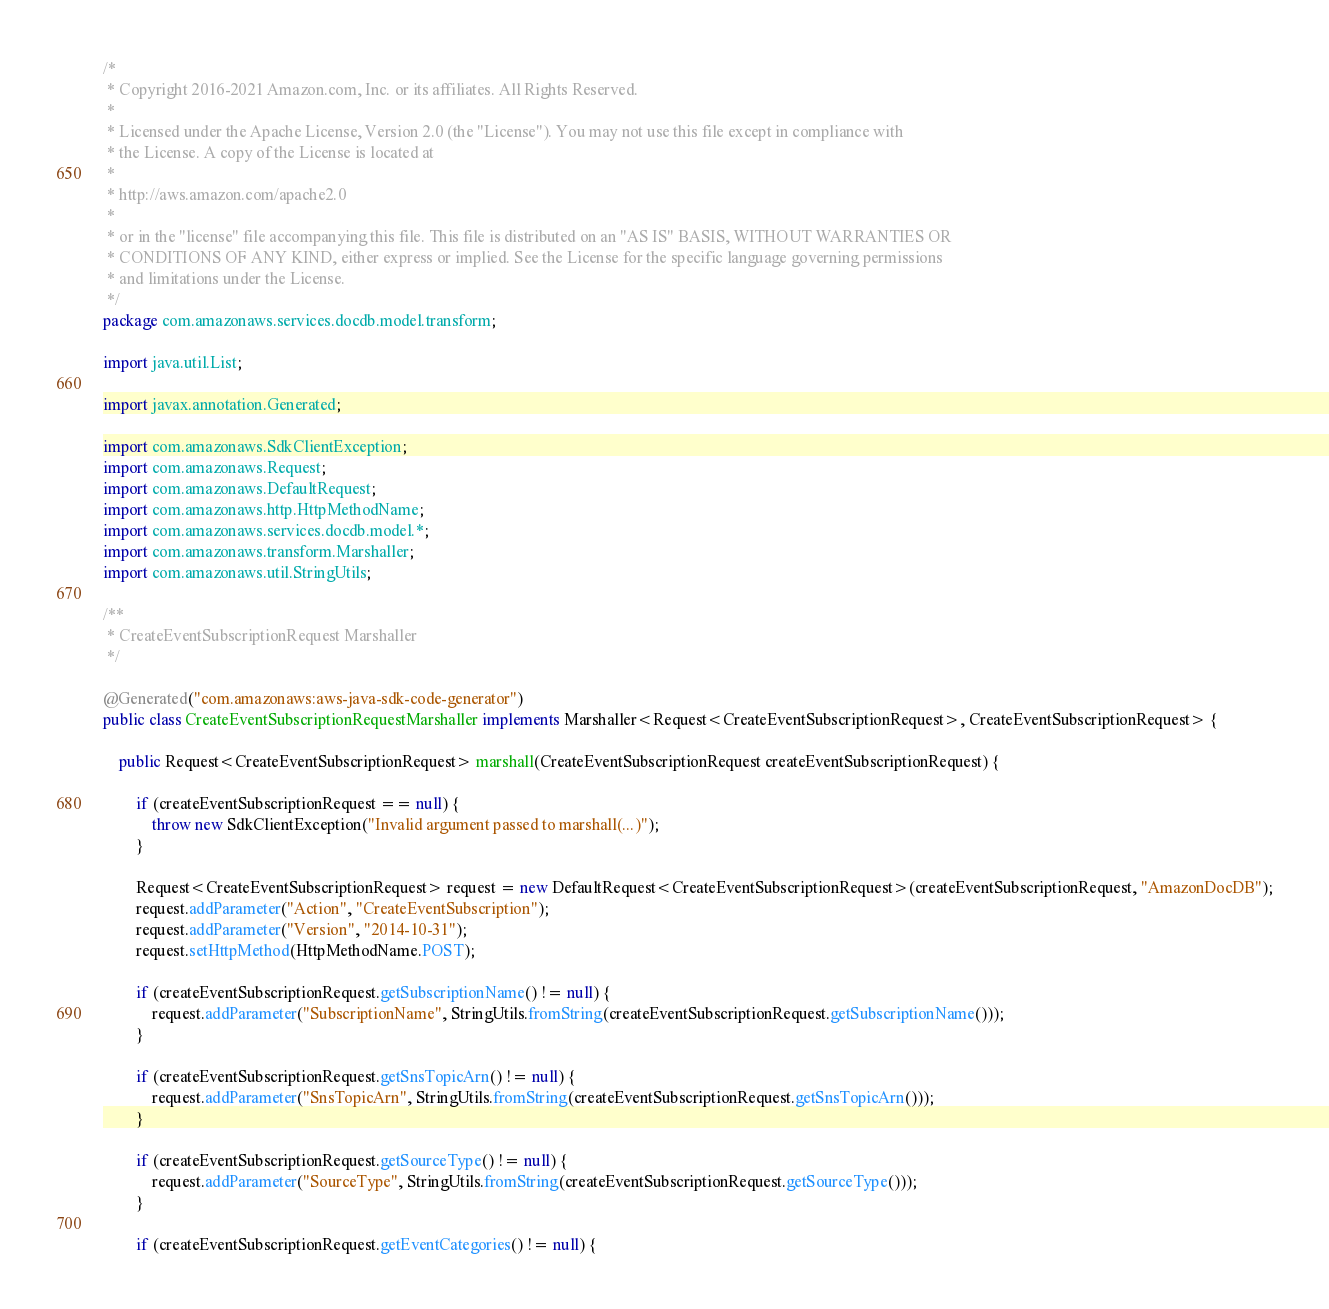<code> <loc_0><loc_0><loc_500><loc_500><_Java_>/*
 * Copyright 2016-2021 Amazon.com, Inc. or its affiliates. All Rights Reserved.
 * 
 * Licensed under the Apache License, Version 2.0 (the "License"). You may not use this file except in compliance with
 * the License. A copy of the License is located at
 * 
 * http://aws.amazon.com/apache2.0
 * 
 * or in the "license" file accompanying this file. This file is distributed on an "AS IS" BASIS, WITHOUT WARRANTIES OR
 * CONDITIONS OF ANY KIND, either express or implied. See the License for the specific language governing permissions
 * and limitations under the License.
 */
package com.amazonaws.services.docdb.model.transform;

import java.util.List;

import javax.annotation.Generated;

import com.amazonaws.SdkClientException;
import com.amazonaws.Request;
import com.amazonaws.DefaultRequest;
import com.amazonaws.http.HttpMethodName;
import com.amazonaws.services.docdb.model.*;
import com.amazonaws.transform.Marshaller;
import com.amazonaws.util.StringUtils;

/**
 * CreateEventSubscriptionRequest Marshaller
 */

@Generated("com.amazonaws:aws-java-sdk-code-generator")
public class CreateEventSubscriptionRequestMarshaller implements Marshaller<Request<CreateEventSubscriptionRequest>, CreateEventSubscriptionRequest> {

    public Request<CreateEventSubscriptionRequest> marshall(CreateEventSubscriptionRequest createEventSubscriptionRequest) {

        if (createEventSubscriptionRequest == null) {
            throw new SdkClientException("Invalid argument passed to marshall(...)");
        }

        Request<CreateEventSubscriptionRequest> request = new DefaultRequest<CreateEventSubscriptionRequest>(createEventSubscriptionRequest, "AmazonDocDB");
        request.addParameter("Action", "CreateEventSubscription");
        request.addParameter("Version", "2014-10-31");
        request.setHttpMethod(HttpMethodName.POST);

        if (createEventSubscriptionRequest.getSubscriptionName() != null) {
            request.addParameter("SubscriptionName", StringUtils.fromString(createEventSubscriptionRequest.getSubscriptionName()));
        }

        if (createEventSubscriptionRequest.getSnsTopicArn() != null) {
            request.addParameter("SnsTopicArn", StringUtils.fromString(createEventSubscriptionRequest.getSnsTopicArn()));
        }

        if (createEventSubscriptionRequest.getSourceType() != null) {
            request.addParameter("SourceType", StringUtils.fromString(createEventSubscriptionRequest.getSourceType()));
        }

        if (createEventSubscriptionRequest.getEventCategories() != null) {</code> 